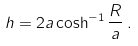Convert formula to latex. <formula><loc_0><loc_0><loc_500><loc_500>h = 2 a \cosh ^ { - 1 } \frac { R } { a } \, .</formula> 